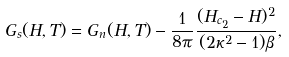Convert formula to latex. <formula><loc_0><loc_0><loc_500><loc_500>G _ { s } ( H , T ) = G _ { n } ( H , T ) - \frac { 1 } { 8 \pi } \frac { ( H _ { c _ { 2 } } - H ) ^ { 2 } } { ( 2 \kappa ^ { 2 } - 1 ) \beta } ,</formula> 